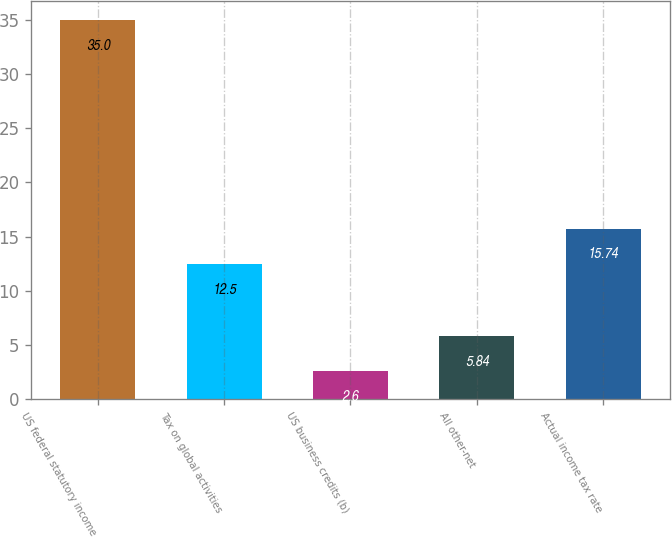Convert chart. <chart><loc_0><loc_0><loc_500><loc_500><bar_chart><fcel>US federal statutory income<fcel>Tax on global activities<fcel>US business credits (b)<fcel>All other-net<fcel>Actual income tax rate<nl><fcel>35<fcel>12.5<fcel>2.6<fcel>5.84<fcel>15.74<nl></chart> 